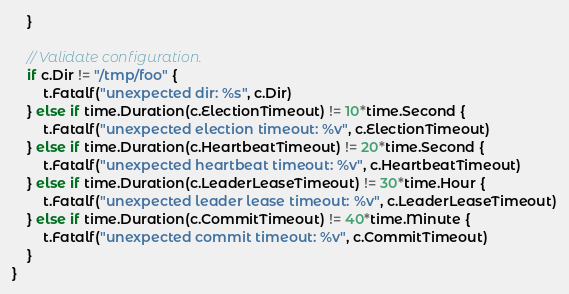<code> <loc_0><loc_0><loc_500><loc_500><_Go_>	}

	// Validate configuration.
	if c.Dir != "/tmp/foo" {
		t.Fatalf("unexpected dir: %s", c.Dir)
	} else if time.Duration(c.ElectionTimeout) != 10*time.Second {
		t.Fatalf("unexpected election timeout: %v", c.ElectionTimeout)
	} else if time.Duration(c.HeartbeatTimeout) != 20*time.Second {
		t.Fatalf("unexpected heartbeat timeout: %v", c.HeartbeatTimeout)
	} else if time.Duration(c.LeaderLeaseTimeout) != 30*time.Hour {
		t.Fatalf("unexpected leader lease timeout: %v", c.LeaderLeaseTimeout)
	} else if time.Duration(c.CommitTimeout) != 40*time.Minute {
		t.Fatalf("unexpected commit timeout: %v", c.CommitTimeout)
	}
}
</code> 